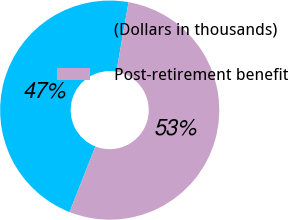Convert chart. <chart><loc_0><loc_0><loc_500><loc_500><pie_chart><fcel>(Dollars in thousands)<fcel>Post-retirement benefit<nl><fcel>46.79%<fcel>53.21%<nl></chart> 